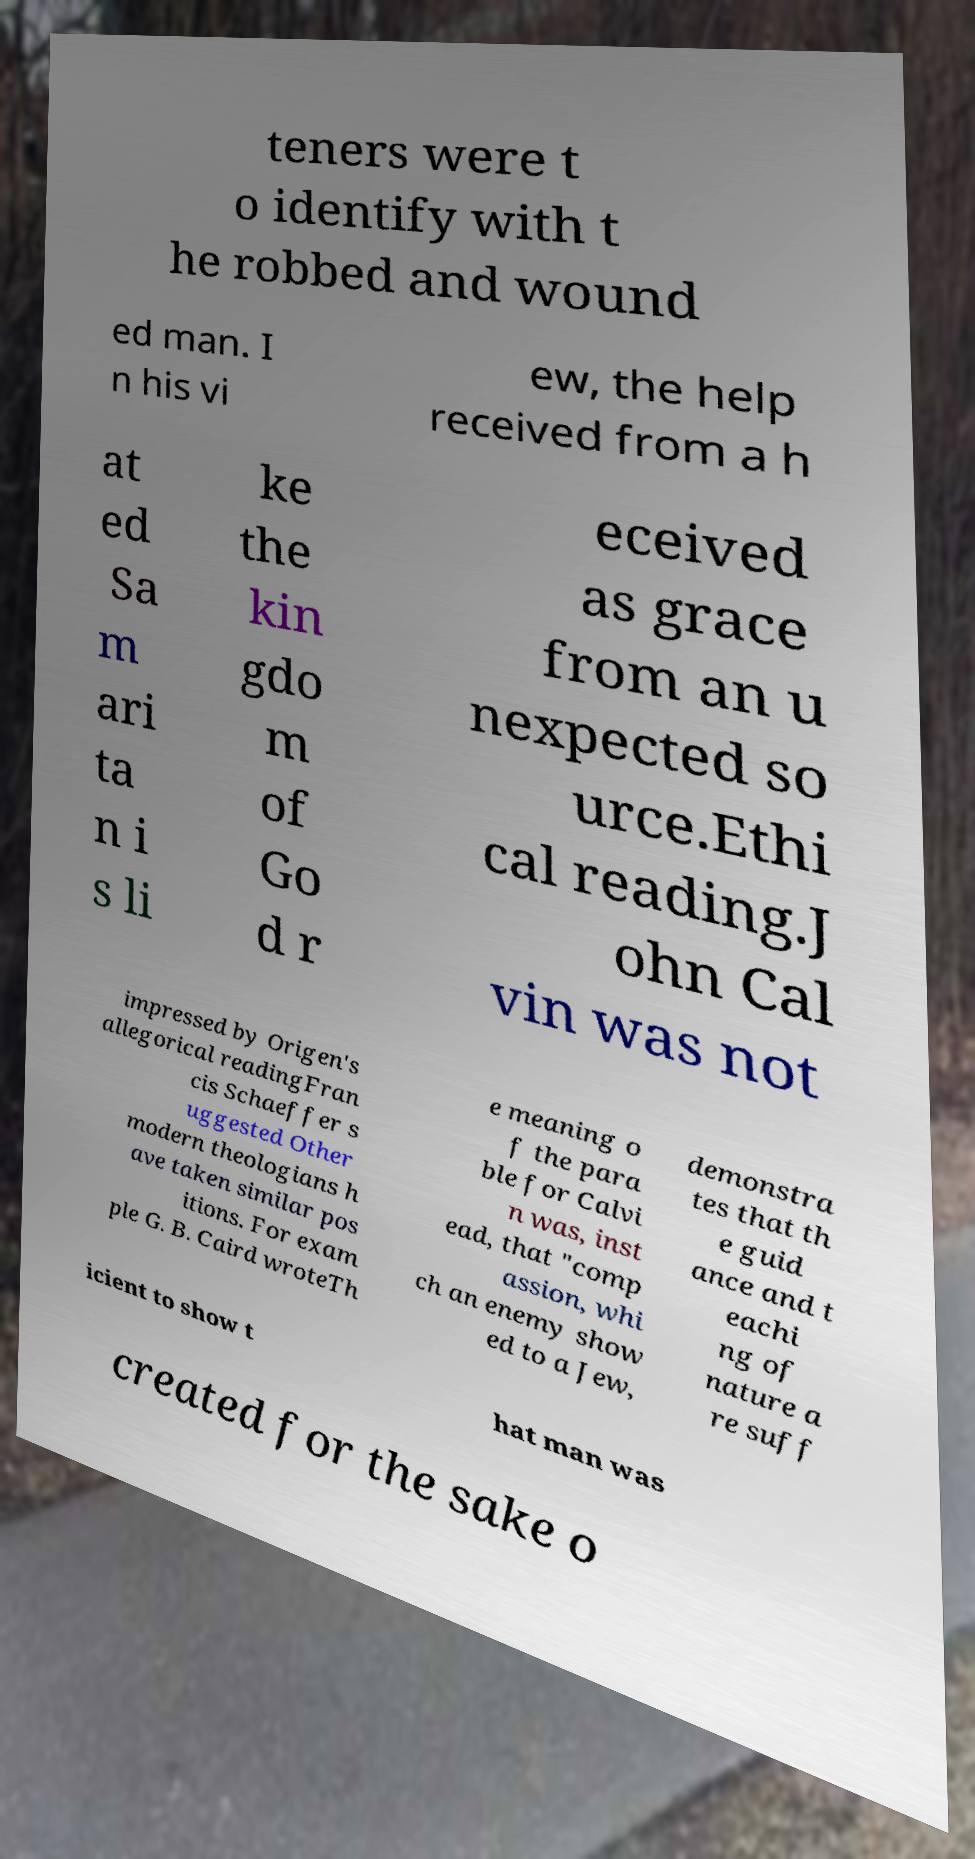What messages or text are displayed in this image? I need them in a readable, typed format. teners were t o identify with t he robbed and wound ed man. I n his vi ew, the help received from a h at ed Sa m ari ta n i s li ke the kin gdo m of Go d r eceived as grace from an u nexpected so urce.Ethi cal reading.J ohn Cal vin was not impressed by Origen's allegorical readingFran cis Schaeffer s uggested Other modern theologians h ave taken similar pos itions. For exam ple G. B. Caird wroteTh e meaning o f the para ble for Calvi n was, inst ead, that "comp assion, whi ch an enemy show ed to a Jew, demonstra tes that th e guid ance and t eachi ng of nature a re suff icient to show t hat man was created for the sake o 